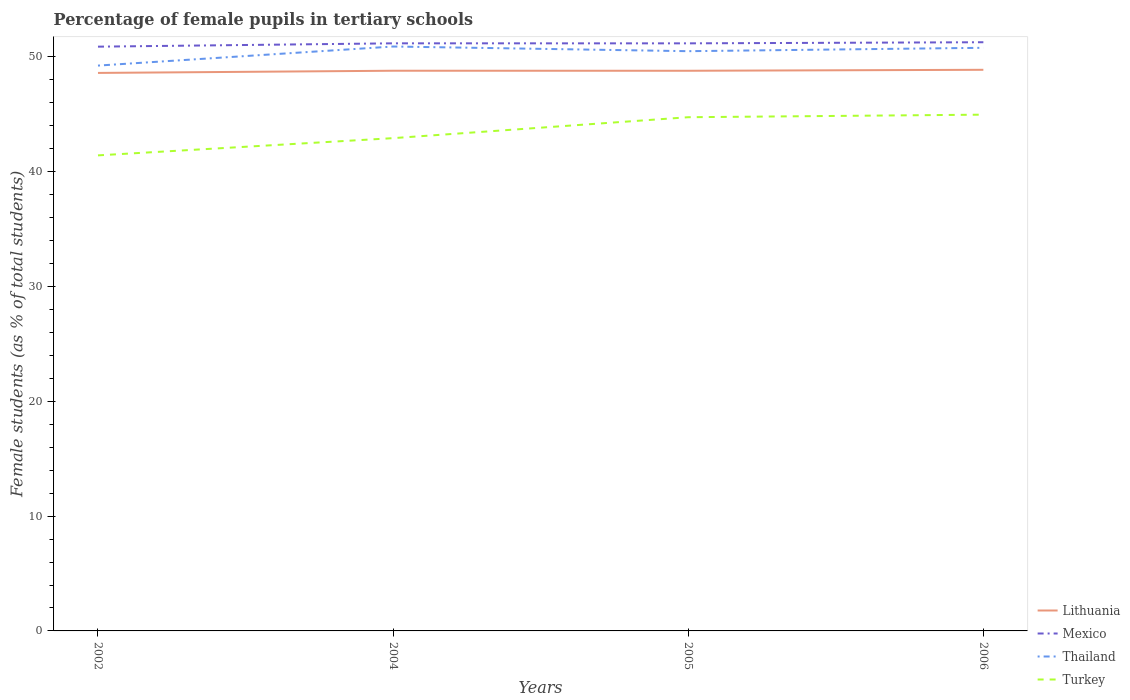Is the number of lines equal to the number of legend labels?
Make the answer very short. Yes. Across all years, what is the maximum percentage of female pupils in tertiary schools in Thailand?
Provide a short and direct response. 49.25. In which year was the percentage of female pupils in tertiary schools in Lithuania maximum?
Your response must be concise. 2002. What is the total percentage of female pupils in tertiary schools in Thailand in the graph?
Provide a succinct answer. 0.11. What is the difference between the highest and the second highest percentage of female pupils in tertiary schools in Turkey?
Your answer should be compact. 3.55. How many lines are there?
Your answer should be compact. 4. How many years are there in the graph?
Offer a very short reply. 4. What is the difference between two consecutive major ticks on the Y-axis?
Give a very brief answer. 10. Are the values on the major ticks of Y-axis written in scientific E-notation?
Provide a short and direct response. No. Does the graph contain any zero values?
Keep it short and to the point. No. Does the graph contain grids?
Ensure brevity in your answer.  No. How many legend labels are there?
Offer a very short reply. 4. What is the title of the graph?
Make the answer very short. Percentage of female pupils in tertiary schools. What is the label or title of the X-axis?
Make the answer very short. Years. What is the label or title of the Y-axis?
Offer a very short reply. Female students (as % of total students). What is the Female students (as % of total students) in Lithuania in 2002?
Your answer should be very brief. 48.61. What is the Female students (as % of total students) in Mexico in 2002?
Provide a succinct answer. 50.89. What is the Female students (as % of total students) in Thailand in 2002?
Make the answer very short. 49.25. What is the Female students (as % of total students) in Turkey in 2002?
Keep it short and to the point. 41.42. What is the Female students (as % of total students) of Lithuania in 2004?
Your answer should be compact. 48.8. What is the Female students (as % of total students) of Mexico in 2004?
Your answer should be very brief. 51.18. What is the Female students (as % of total students) in Thailand in 2004?
Give a very brief answer. 50.91. What is the Female students (as % of total students) of Turkey in 2004?
Your response must be concise. 42.93. What is the Female students (as % of total students) in Lithuania in 2005?
Give a very brief answer. 48.79. What is the Female students (as % of total students) of Mexico in 2005?
Your response must be concise. 51.18. What is the Female students (as % of total students) in Thailand in 2005?
Keep it short and to the point. 50.5. What is the Female students (as % of total students) of Turkey in 2005?
Your answer should be compact. 44.75. What is the Female students (as % of total students) in Lithuania in 2006?
Provide a succinct answer. 48.88. What is the Female students (as % of total students) of Mexico in 2006?
Your answer should be very brief. 51.28. What is the Female students (as % of total students) of Thailand in 2006?
Provide a short and direct response. 50.8. What is the Female students (as % of total students) of Turkey in 2006?
Provide a succinct answer. 44.97. Across all years, what is the maximum Female students (as % of total students) in Lithuania?
Your answer should be compact. 48.88. Across all years, what is the maximum Female students (as % of total students) in Mexico?
Offer a very short reply. 51.28. Across all years, what is the maximum Female students (as % of total students) of Thailand?
Keep it short and to the point. 50.91. Across all years, what is the maximum Female students (as % of total students) of Turkey?
Provide a succinct answer. 44.97. Across all years, what is the minimum Female students (as % of total students) of Lithuania?
Provide a succinct answer. 48.61. Across all years, what is the minimum Female students (as % of total students) in Mexico?
Give a very brief answer. 50.89. Across all years, what is the minimum Female students (as % of total students) in Thailand?
Your answer should be very brief. 49.25. Across all years, what is the minimum Female students (as % of total students) of Turkey?
Keep it short and to the point. 41.42. What is the total Female students (as % of total students) in Lithuania in the graph?
Offer a terse response. 195.08. What is the total Female students (as % of total students) in Mexico in the graph?
Keep it short and to the point. 204.54. What is the total Female students (as % of total students) in Thailand in the graph?
Your answer should be very brief. 201.45. What is the total Female students (as % of total students) in Turkey in the graph?
Provide a short and direct response. 174.07. What is the difference between the Female students (as % of total students) of Lithuania in 2002 and that in 2004?
Your answer should be compact. -0.19. What is the difference between the Female students (as % of total students) in Mexico in 2002 and that in 2004?
Give a very brief answer. -0.29. What is the difference between the Female students (as % of total students) of Thailand in 2002 and that in 2004?
Provide a short and direct response. -1.66. What is the difference between the Female students (as % of total students) of Turkey in 2002 and that in 2004?
Make the answer very short. -1.5. What is the difference between the Female students (as % of total students) in Lithuania in 2002 and that in 2005?
Your answer should be very brief. -0.19. What is the difference between the Female students (as % of total students) in Mexico in 2002 and that in 2005?
Your response must be concise. -0.29. What is the difference between the Female students (as % of total students) of Thailand in 2002 and that in 2005?
Your answer should be very brief. -1.25. What is the difference between the Female students (as % of total students) in Turkey in 2002 and that in 2005?
Give a very brief answer. -3.32. What is the difference between the Female students (as % of total students) of Lithuania in 2002 and that in 2006?
Provide a short and direct response. -0.27. What is the difference between the Female students (as % of total students) in Mexico in 2002 and that in 2006?
Offer a terse response. -0.39. What is the difference between the Female students (as % of total students) in Thailand in 2002 and that in 2006?
Give a very brief answer. -1.55. What is the difference between the Female students (as % of total students) of Turkey in 2002 and that in 2006?
Your answer should be very brief. -3.55. What is the difference between the Female students (as % of total students) of Lithuania in 2004 and that in 2005?
Your response must be concise. 0. What is the difference between the Female students (as % of total students) in Mexico in 2004 and that in 2005?
Give a very brief answer. 0. What is the difference between the Female students (as % of total students) of Thailand in 2004 and that in 2005?
Provide a succinct answer. 0.41. What is the difference between the Female students (as % of total students) of Turkey in 2004 and that in 2005?
Your response must be concise. -1.82. What is the difference between the Female students (as % of total students) of Lithuania in 2004 and that in 2006?
Ensure brevity in your answer.  -0.08. What is the difference between the Female students (as % of total students) in Mexico in 2004 and that in 2006?
Offer a terse response. -0.1. What is the difference between the Female students (as % of total students) of Thailand in 2004 and that in 2006?
Your answer should be very brief. 0.11. What is the difference between the Female students (as % of total students) of Turkey in 2004 and that in 2006?
Your response must be concise. -2.05. What is the difference between the Female students (as % of total students) in Lithuania in 2005 and that in 2006?
Your answer should be very brief. -0.09. What is the difference between the Female students (as % of total students) of Mexico in 2005 and that in 2006?
Provide a short and direct response. -0.1. What is the difference between the Female students (as % of total students) of Thailand in 2005 and that in 2006?
Your answer should be very brief. -0.29. What is the difference between the Female students (as % of total students) in Turkey in 2005 and that in 2006?
Give a very brief answer. -0.22. What is the difference between the Female students (as % of total students) in Lithuania in 2002 and the Female students (as % of total students) in Mexico in 2004?
Provide a succinct answer. -2.58. What is the difference between the Female students (as % of total students) of Lithuania in 2002 and the Female students (as % of total students) of Thailand in 2004?
Provide a succinct answer. -2.3. What is the difference between the Female students (as % of total students) of Lithuania in 2002 and the Female students (as % of total students) of Turkey in 2004?
Offer a very short reply. 5.68. What is the difference between the Female students (as % of total students) in Mexico in 2002 and the Female students (as % of total students) in Thailand in 2004?
Make the answer very short. -0.01. What is the difference between the Female students (as % of total students) of Mexico in 2002 and the Female students (as % of total students) of Turkey in 2004?
Your response must be concise. 7.97. What is the difference between the Female students (as % of total students) of Thailand in 2002 and the Female students (as % of total students) of Turkey in 2004?
Keep it short and to the point. 6.32. What is the difference between the Female students (as % of total students) in Lithuania in 2002 and the Female students (as % of total students) in Mexico in 2005?
Ensure brevity in your answer.  -2.58. What is the difference between the Female students (as % of total students) in Lithuania in 2002 and the Female students (as % of total students) in Thailand in 2005?
Ensure brevity in your answer.  -1.89. What is the difference between the Female students (as % of total students) in Lithuania in 2002 and the Female students (as % of total students) in Turkey in 2005?
Your answer should be very brief. 3.86. What is the difference between the Female students (as % of total students) in Mexico in 2002 and the Female students (as % of total students) in Thailand in 2005?
Provide a succinct answer. 0.39. What is the difference between the Female students (as % of total students) of Mexico in 2002 and the Female students (as % of total students) of Turkey in 2005?
Offer a very short reply. 6.15. What is the difference between the Female students (as % of total students) of Thailand in 2002 and the Female students (as % of total students) of Turkey in 2005?
Your answer should be very brief. 4.5. What is the difference between the Female students (as % of total students) in Lithuania in 2002 and the Female students (as % of total students) in Mexico in 2006?
Offer a terse response. -2.67. What is the difference between the Female students (as % of total students) in Lithuania in 2002 and the Female students (as % of total students) in Thailand in 2006?
Your answer should be compact. -2.19. What is the difference between the Female students (as % of total students) of Lithuania in 2002 and the Female students (as % of total students) of Turkey in 2006?
Your answer should be compact. 3.64. What is the difference between the Female students (as % of total students) of Mexico in 2002 and the Female students (as % of total students) of Thailand in 2006?
Give a very brief answer. 0.1. What is the difference between the Female students (as % of total students) of Mexico in 2002 and the Female students (as % of total students) of Turkey in 2006?
Offer a very short reply. 5.92. What is the difference between the Female students (as % of total students) in Thailand in 2002 and the Female students (as % of total students) in Turkey in 2006?
Give a very brief answer. 4.27. What is the difference between the Female students (as % of total students) in Lithuania in 2004 and the Female students (as % of total students) in Mexico in 2005?
Make the answer very short. -2.39. What is the difference between the Female students (as % of total students) in Lithuania in 2004 and the Female students (as % of total students) in Thailand in 2005?
Your response must be concise. -1.7. What is the difference between the Female students (as % of total students) in Lithuania in 2004 and the Female students (as % of total students) in Turkey in 2005?
Your response must be concise. 4.05. What is the difference between the Female students (as % of total students) in Mexico in 2004 and the Female students (as % of total students) in Thailand in 2005?
Offer a very short reply. 0.68. What is the difference between the Female students (as % of total students) in Mexico in 2004 and the Female students (as % of total students) in Turkey in 2005?
Your answer should be very brief. 6.44. What is the difference between the Female students (as % of total students) of Thailand in 2004 and the Female students (as % of total students) of Turkey in 2005?
Give a very brief answer. 6.16. What is the difference between the Female students (as % of total students) of Lithuania in 2004 and the Female students (as % of total students) of Mexico in 2006?
Your answer should be very brief. -2.48. What is the difference between the Female students (as % of total students) in Lithuania in 2004 and the Female students (as % of total students) in Thailand in 2006?
Provide a succinct answer. -2. What is the difference between the Female students (as % of total students) of Lithuania in 2004 and the Female students (as % of total students) of Turkey in 2006?
Offer a terse response. 3.83. What is the difference between the Female students (as % of total students) in Mexico in 2004 and the Female students (as % of total students) in Thailand in 2006?
Ensure brevity in your answer.  0.39. What is the difference between the Female students (as % of total students) in Mexico in 2004 and the Female students (as % of total students) in Turkey in 2006?
Offer a terse response. 6.21. What is the difference between the Female students (as % of total students) of Thailand in 2004 and the Female students (as % of total students) of Turkey in 2006?
Ensure brevity in your answer.  5.94. What is the difference between the Female students (as % of total students) of Lithuania in 2005 and the Female students (as % of total students) of Mexico in 2006?
Keep it short and to the point. -2.49. What is the difference between the Female students (as % of total students) in Lithuania in 2005 and the Female students (as % of total students) in Thailand in 2006?
Your answer should be very brief. -2. What is the difference between the Female students (as % of total students) in Lithuania in 2005 and the Female students (as % of total students) in Turkey in 2006?
Keep it short and to the point. 3.82. What is the difference between the Female students (as % of total students) in Mexico in 2005 and the Female students (as % of total students) in Thailand in 2006?
Make the answer very short. 0.39. What is the difference between the Female students (as % of total students) in Mexico in 2005 and the Female students (as % of total students) in Turkey in 2006?
Keep it short and to the point. 6.21. What is the difference between the Female students (as % of total students) in Thailand in 2005 and the Female students (as % of total students) in Turkey in 2006?
Your response must be concise. 5.53. What is the average Female students (as % of total students) of Lithuania per year?
Keep it short and to the point. 48.77. What is the average Female students (as % of total students) of Mexico per year?
Keep it short and to the point. 51.14. What is the average Female students (as % of total students) in Thailand per year?
Your answer should be very brief. 50.36. What is the average Female students (as % of total students) in Turkey per year?
Your response must be concise. 43.52. In the year 2002, what is the difference between the Female students (as % of total students) of Lithuania and Female students (as % of total students) of Mexico?
Your answer should be compact. -2.29. In the year 2002, what is the difference between the Female students (as % of total students) in Lithuania and Female students (as % of total students) in Thailand?
Your response must be concise. -0.64. In the year 2002, what is the difference between the Female students (as % of total students) in Lithuania and Female students (as % of total students) in Turkey?
Your answer should be compact. 7.18. In the year 2002, what is the difference between the Female students (as % of total students) in Mexico and Female students (as % of total students) in Thailand?
Provide a succinct answer. 1.65. In the year 2002, what is the difference between the Female students (as % of total students) of Mexico and Female students (as % of total students) of Turkey?
Your response must be concise. 9.47. In the year 2002, what is the difference between the Female students (as % of total students) in Thailand and Female students (as % of total students) in Turkey?
Keep it short and to the point. 7.82. In the year 2004, what is the difference between the Female students (as % of total students) of Lithuania and Female students (as % of total students) of Mexico?
Ensure brevity in your answer.  -2.39. In the year 2004, what is the difference between the Female students (as % of total students) of Lithuania and Female students (as % of total students) of Thailand?
Provide a succinct answer. -2.11. In the year 2004, what is the difference between the Female students (as % of total students) of Lithuania and Female students (as % of total students) of Turkey?
Your response must be concise. 5.87. In the year 2004, what is the difference between the Female students (as % of total students) in Mexico and Female students (as % of total students) in Thailand?
Offer a very short reply. 0.28. In the year 2004, what is the difference between the Female students (as % of total students) in Mexico and Female students (as % of total students) in Turkey?
Your answer should be very brief. 8.26. In the year 2004, what is the difference between the Female students (as % of total students) in Thailand and Female students (as % of total students) in Turkey?
Your response must be concise. 7.98. In the year 2005, what is the difference between the Female students (as % of total students) in Lithuania and Female students (as % of total students) in Mexico?
Provide a short and direct response. -2.39. In the year 2005, what is the difference between the Female students (as % of total students) in Lithuania and Female students (as % of total students) in Thailand?
Make the answer very short. -1.71. In the year 2005, what is the difference between the Female students (as % of total students) of Lithuania and Female students (as % of total students) of Turkey?
Provide a succinct answer. 4.05. In the year 2005, what is the difference between the Female students (as % of total students) of Mexico and Female students (as % of total students) of Thailand?
Your answer should be compact. 0.68. In the year 2005, what is the difference between the Female students (as % of total students) in Mexico and Female students (as % of total students) in Turkey?
Your answer should be compact. 6.43. In the year 2005, what is the difference between the Female students (as % of total students) of Thailand and Female students (as % of total students) of Turkey?
Make the answer very short. 5.75. In the year 2006, what is the difference between the Female students (as % of total students) of Lithuania and Female students (as % of total students) of Mexico?
Keep it short and to the point. -2.4. In the year 2006, what is the difference between the Female students (as % of total students) of Lithuania and Female students (as % of total students) of Thailand?
Offer a very short reply. -1.92. In the year 2006, what is the difference between the Female students (as % of total students) in Lithuania and Female students (as % of total students) in Turkey?
Your answer should be compact. 3.91. In the year 2006, what is the difference between the Female students (as % of total students) in Mexico and Female students (as % of total students) in Thailand?
Give a very brief answer. 0.48. In the year 2006, what is the difference between the Female students (as % of total students) in Mexico and Female students (as % of total students) in Turkey?
Your answer should be compact. 6.31. In the year 2006, what is the difference between the Female students (as % of total students) in Thailand and Female students (as % of total students) in Turkey?
Keep it short and to the point. 5.82. What is the ratio of the Female students (as % of total students) of Lithuania in 2002 to that in 2004?
Your response must be concise. 1. What is the ratio of the Female students (as % of total students) of Mexico in 2002 to that in 2004?
Your answer should be very brief. 0.99. What is the ratio of the Female students (as % of total students) of Thailand in 2002 to that in 2004?
Make the answer very short. 0.97. What is the ratio of the Female students (as % of total students) of Thailand in 2002 to that in 2005?
Give a very brief answer. 0.98. What is the ratio of the Female students (as % of total students) in Turkey in 2002 to that in 2005?
Your answer should be very brief. 0.93. What is the ratio of the Female students (as % of total students) of Lithuania in 2002 to that in 2006?
Provide a short and direct response. 0.99. What is the ratio of the Female students (as % of total students) of Mexico in 2002 to that in 2006?
Give a very brief answer. 0.99. What is the ratio of the Female students (as % of total students) of Thailand in 2002 to that in 2006?
Give a very brief answer. 0.97. What is the ratio of the Female students (as % of total students) in Turkey in 2002 to that in 2006?
Keep it short and to the point. 0.92. What is the ratio of the Female students (as % of total students) of Thailand in 2004 to that in 2005?
Provide a succinct answer. 1.01. What is the ratio of the Female students (as % of total students) in Turkey in 2004 to that in 2005?
Offer a very short reply. 0.96. What is the ratio of the Female students (as % of total students) of Lithuania in 2004 to that in 2006?
Keep it short and to the point. 1. What is the ratio of the Female students (as % of total students) of Mexico in 2004 to that in 2006?
Provide a short and direct response. 1. What is the ratio of the Female students (as % of total students) in Thailand in 2004 to that in 2006?
Keep it short and to the point. 1. What is the ratio of the Female students (as % of total students) in Turkey in 2004 to that in 2006?
Make the answer very short. 0.95. What is the ratio of the Female students (as % of total students) of Thailand in 2005 to that in 2006?
Make the answer very short. 0.99. What is the ratio of the Female students (as % of total students) in Turkey in 2005 to that in 2006?
Your response must be concise. 0.99. What is the difference between the highest and the second highest Female students (as % of total students) of Lithuania?
Make the answer very short. 0.08. What is the difference between the highest and the second highest Female students (as % of total students) in Mexico?
Make the answer very short. 0.1. What is the difference between the highest and the second highest Female students (as % of total students) of Thailand?
Offer a very short reply. 0.11. What is the difference between the highest and the second highest Female students (as % of total students) of Turkey?
Make the answer very short. 0.22. What is the difference between the highest and the lowest Female students (as % of total students) of Lithuania?
Keep it short and to the point. 0.27. What is the difference between the highest and the lowest Female students (as % of total students) of Mexico?
Your answer should be very brief. 0.39. What is the difference between the highest and the lowest Female students (as % of total students) of Thailand?
Keep it short and to the point. 1.66. What is the difference between the highest and the lowest Female students (as % of total students) of Turkey?
Offer a terse response. 3.55. 